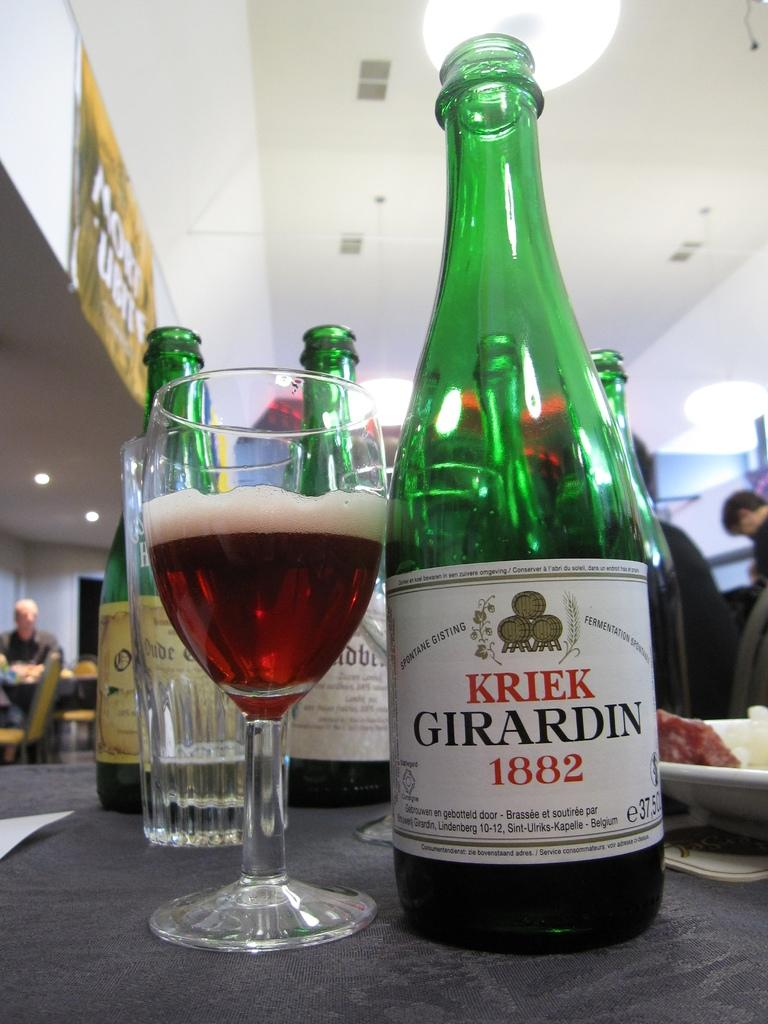What is the color of the wall in the image? The wall in the image is white. What can be seen hanging on the wall? There is a banner in the image. What type of furniture is present in the image? There are tables in the image. What items are on the tables? There are bottles and glasses on the table. How many jellyfish can be seen swimming in the image? There are no jellyfish present in the image. What type of wave can be seen in the image? There is no wave present in the image. 